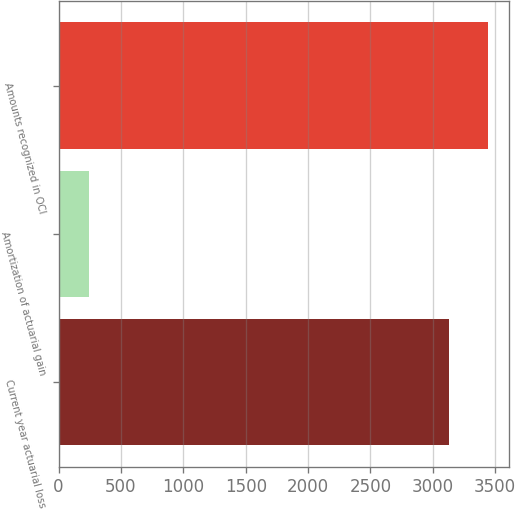<chart> <loc_0><loc_0><loc_500><loc_500><bar_chart><fcel>Current year actuarial loss<fcel>Amortization of actuarial gain<fcel>Amounts recognized in OCI<nl><fcel>3128<fcel>242<fcel>3440.8<nl></chart> 